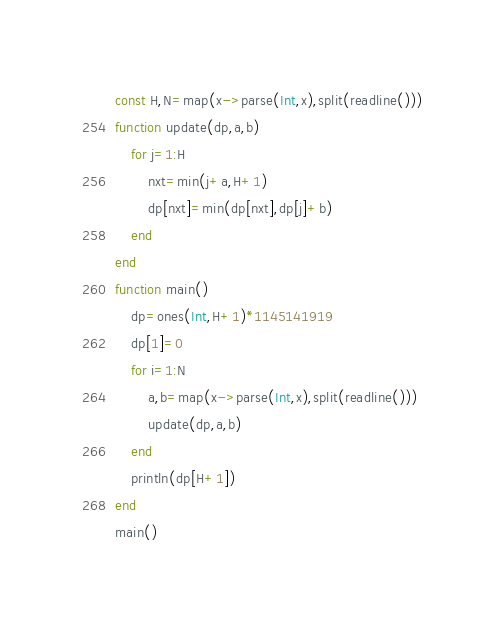<code> <loc_0><loc_0><loc_500><loc_500><_Julia_>const H,N=map(x->parse(Int,x),split(readline()))
function update(dp,a,b)
	for j=1:H
		nxt=min(j+a,H+1)
		dp[nxt]=min(dp[nxt],dp[j]+b)
	end
end
function main()
	dp=ones(Int,H+1)*1145141919
	dp[1]=0
	for i=1:N
		a,b=map(x->parse(Int,x),split(readline()))
		update(dp,a,b)
	end
	println(dp[H+1])
end
main()</code> 